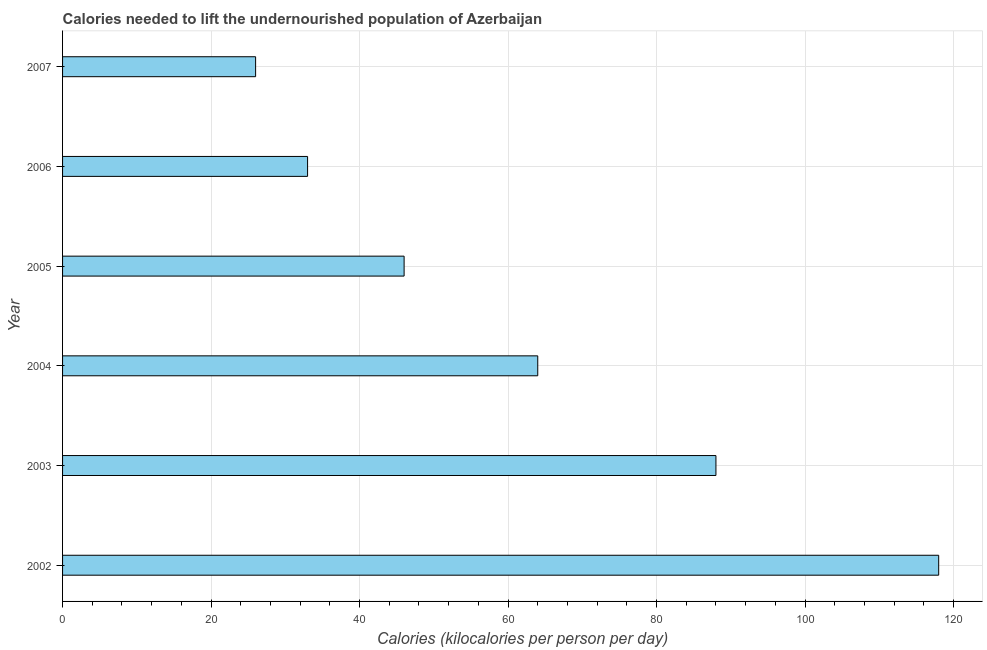Does the graph contain grids?
Your answer should be very brief. Yes. What is the title of the graph?
Offer a very short reply. Calories needed to lift the undernourished population of Azerbaijan. What is the label or title of the X-axis?
Give a very brief answer. Calories (kilocalories per person per day). Across all years, what is the maximum depth of food deficit?
Make the answer very short. 118. Across all years, what is the minimum depth of food deficit?
Keep it short and to the point. 26. In which year was the depth of food deficit maximum?
Give a very brief answer. 2002. What is the sum of the depth of food deficit?
Your answer should be compact. 375. What is the difference between the depth of food deficit in 2002 and 2004?
Give a very brief answer. 54. What is the median depth of food deficit?
Your response must be concise. 55. Do a majority of the years between 2006 and 2004 (inclusive) have depth of food deficit greater than 40 kilocalories?
Ensure brevity in your answer.  Yes. What is the ratio of the depth of food deficit in 2002 to that in 2006?
Keep it short and to the point. 3.58. Is the difference between the depth of food deficit in 2002 and 2004 greater than the difference between any two years?
Make the answer very short. No. What is the difference between the highest and the second highest depth of food deficit?
Your answer should be very brief. 30. What is the difference between the highest and the lowest depth of food deficit?
Make the answer very short. 92. How many bars are there?
Your answer should be compact. 6. Are the values on the major ticks of X-axis written in scientific E-notation?
Provide a short and direct response. No. What is the Calories (kilocalories per person per day) of 2002?
Your answer should be compact. 118. What is the Calories (kilocalories per person per day) in 2004?
Ensure brevity in your answer.  64. What is the difference between the Calories (kilocalories per person per day) in 2002 and 2003?
Keep it short and to the point. 30. What is the difference between the Calories (kilocalories per person per day) in 2002 and 2005?
Make the answer very short. 72. What is the difference between the Calories (kilocalories per person per day) in 2002 and 2006?
Offer a very short reply. 85. What is the difference between the Calories (kilocalories per person per day) in 2002 and 2007?
Offer a terse response. 92. What is the difference between the Calories (kilocalories per person per day) in 2003 and 2007?
Your answer should be compact. 62. What is the difference between the Calories (kilocalories per person per day) in 2004 and 2005?
Your answer should be compact. 18. What is the difference between the Calories (kilocalories per person per day) in 2004 and 2006?
Provide a short and direct response. 31. What is the difference between the Calories (kilocalories per person per day) in 2004 and 2007?
Offer a very short reply. 38. What is the difference between the Calories (kilocalories per person per day) in 2005 and 2006?
Offer a terse response. 13. What is the difference between the Calories (kilocalories per person per day) in 2005 and 2007?
Give a very brief answer. 20. What is the difference between the Calories (kilocalories per person per day) in 2006 and 2007?
Your answer should be compact. 7. What is the ratio of the Calories (kilocalories per person per day) in 2002 to that in 2003?
Your answer should be compact. 1.34. What is the ratio of the Calories (kilocalories per person per day) in 2002 to that in 2004?
Provide a succinct answer. 1.84. What is the ratio of the Calories (kilocalories per person per day) in 2002 to that in 2005?
Give a very brief answer. 2.56. What is the ratio of the Calories (kilocalories per person per day) in 2002 to that in 2006?
Keep it short and to the point. 3.58. What is the ratio of the Calories (kilocalories per person per day) in 2002 to that in 2007?
Provide a succinct answer. 4.54. What is the ratio of the Calories (kilocalories per person per day) in 2003 to that in 2004?
Make the answer very short. 1.38. What is the ratio of the Calories (kilocalories per person per day) in 2003 to that in 2005?
Give a very brief answer. 1.91. What is the ratio of the Calories (kilocalories per person per day) in 2003 to that in 2006?
Your answer should be compact. 2.67. What is the ratio of the Calories (kilocalories per person per day) in 2003 to that in 2007?
Keep it short and to the point. 3.38. What is the ratio of the Calories (kilocalories per person per day) in 2004 to that in 2005?
Keep it short and to the point. 1.39. What is the ratio of the Calories (kilocalories per person per day) in 2004 to that in 2006?
Offer a very short reply. 1.94. What is the ratio of the Calories (kilocalories per person per day) in 2004 to that in 2007?
Ensure brevity in your answer.  2.46. What is the ratio of the Calories (kilocalories per person per day) in 2005 to that in 2006?
Your answer should be very brief. 1.39. What is the ratio of the Calories (kilocalories per person per day) in 2005 to that in 2007?
Provide a short and direct response. 1.77. What is the ratio of the Calories (kilocalories per person per day) in 2006 to that in 2007?
Your response must be concise. 1.27. 